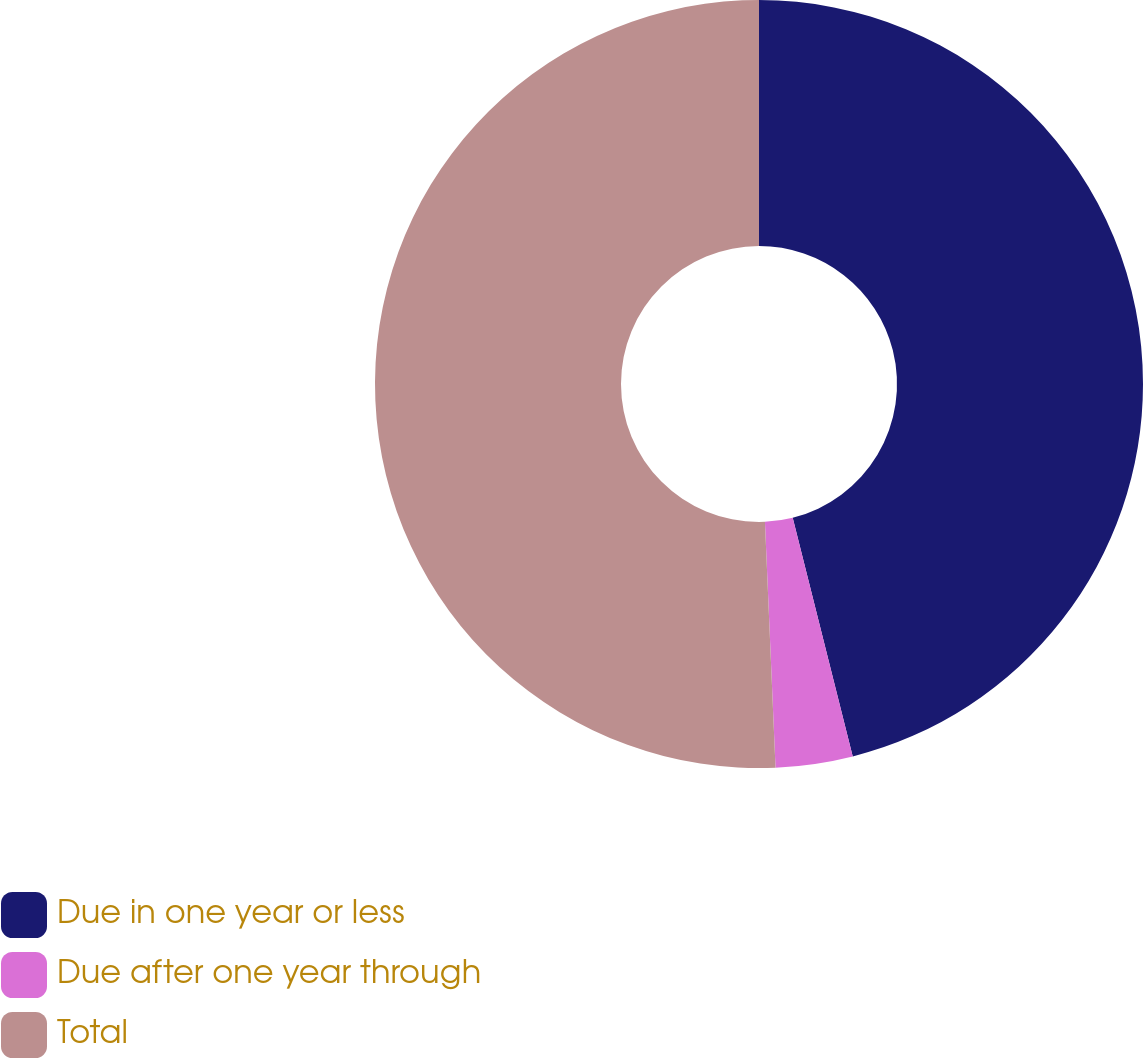Convert chart to OTSL. <chart><loc_0><loc_0><loc_500><loc_500><pie_chart><fcel>Due in one year or less<fcel>Due after one year through<fcel>Total<nl><fcel>46.07%<fcel>3.24%<fcel>50.68%<nl></chart> 